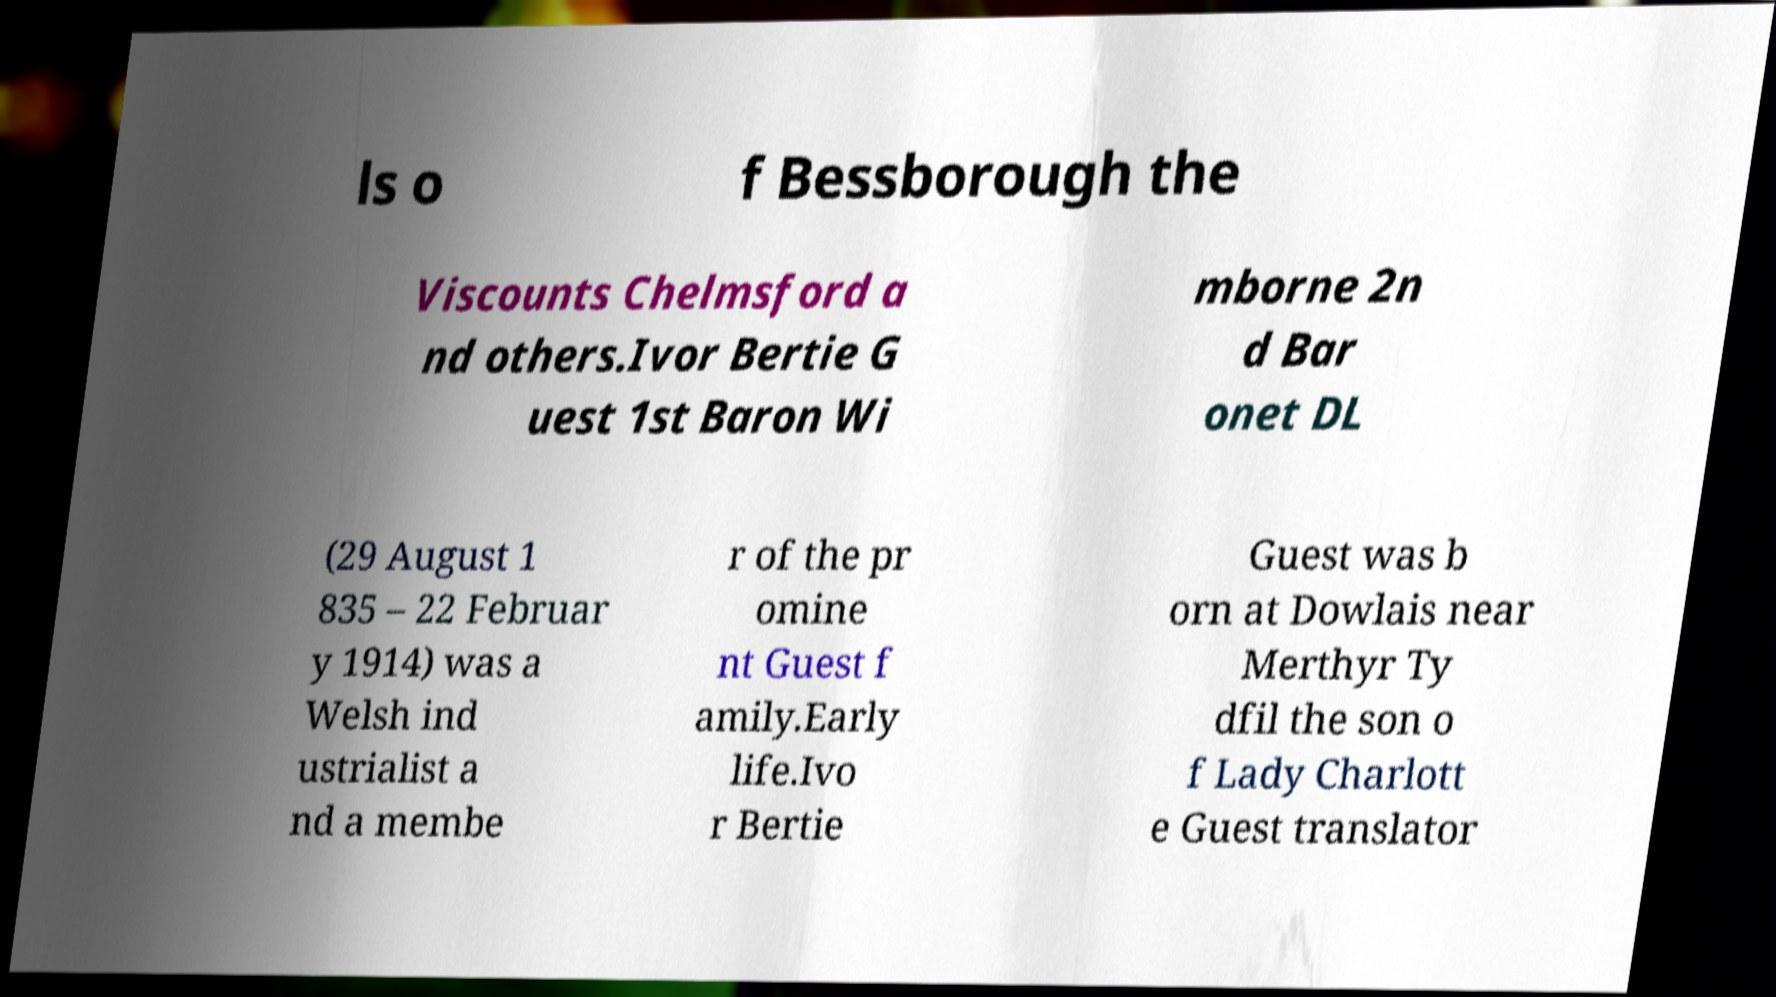Could you extract and type out the text from this image? ls o f Bessborough the Viscounts Chelmsford a nd others.Ivor Bertie G uest 1st Baron Wi mborne 2n d Bar onet DL (29 August 1 835 – 22 Februar y 1914) was a Welsh ind ustrialist a nd a membe r of the pr omine nt Guest f amily.Early life.Ivo r Bertie Guest was b orn at Dowlais near Merthyr Ty dfil the son o f Lady Charlott e Guest translator 